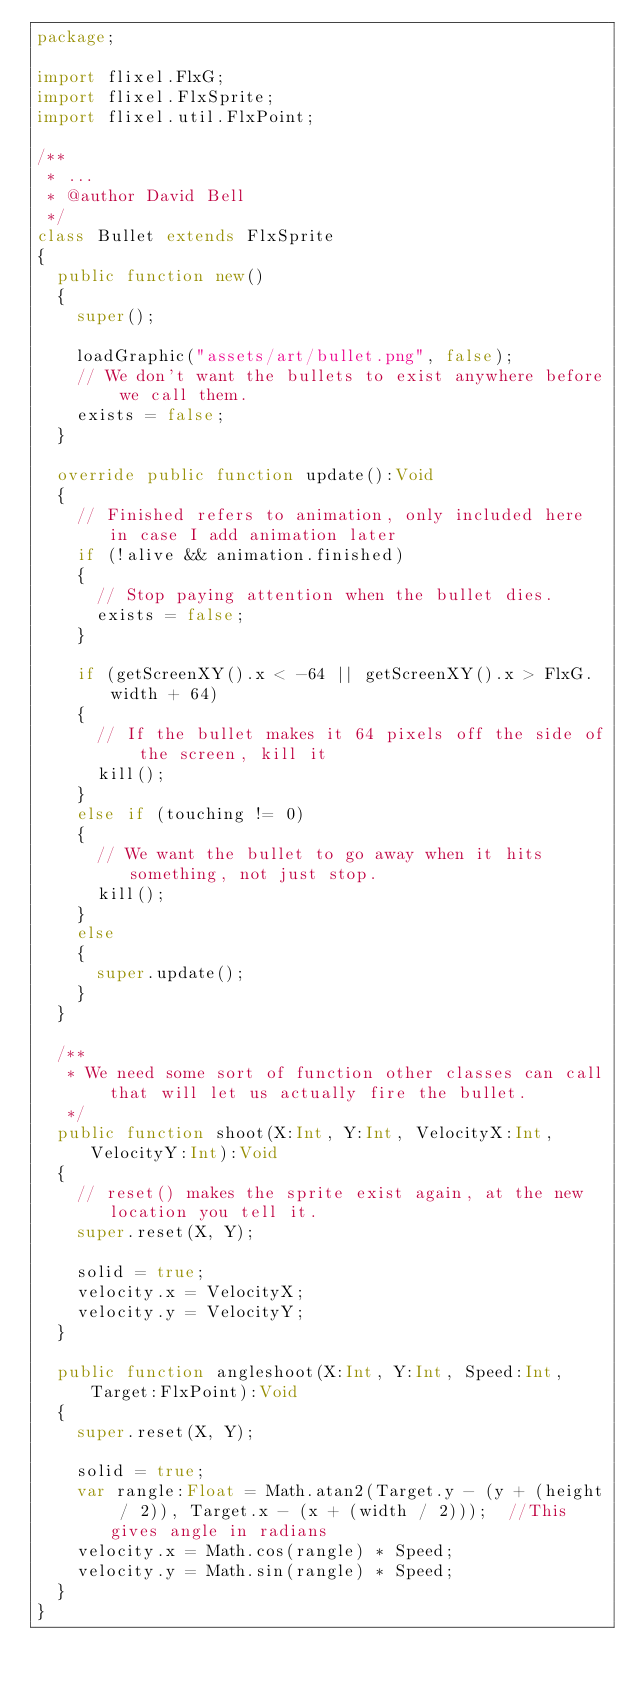<code> <loc_0><loc_0><loc_500><loc_500><_Haxe_>package;

import flixel.FlxG;
import flixel.FlxSprite;
import flixel.util.FlxPoint;

/**
 * ...
 * @author David Bell
 */
class Bullet extends FlxSprite 
{
	public function new() 
	{
		super();
		
		loadGraphic("assets/art/bullet.png", false);
		// We don't want the bullets to exist anywhere before we call them.
		exists = false; 
	}
	
	override public function update():Void 
	{
		// Finished refers to animation, only included here in case I add animation later
		if (!alive && animation.finished) 
		{
			// Stop paying attention when the bullet dies. 
			exists = false;   
		}
		
		if (getScreenXY().x < -64 || getScreenXY().x > FlxG.width + 64) 
		{ 
			// If the bullet makes it 64 pixels off the side of the screen, kill it
			kill(); 
		} 
		else if (touching != 0)
		{
			// We want the bullet to go away when it hits something, not just stop.
			kill(); 
		}
		else
		{
			super.update();
		}
	}
	
	/**
	 * We need some sort of function other classes can call that will let us actually fire the bullet. 
	 */ 
	public function shoot(X:Int, Y:Int, VelocityX:Int, VelocityY:Int):Void
	{
		// reset() makes the sprite exist again, at the new location you tell it.
		super.reset(X, Y);  
		
		solid = true;
		velocity.x = VelocityX;
		velocity.y = VelocityY;
	}
	
	public function angleshoot(X:Int, Y:Int, Speed:Int, Target:FlxPoint):Void
	{
		super.reset(X, Y);
		
		solid = true;
		var rangle:Float = Math.atan2(Target.y - (y + (height / 2)), Target.x - (x + (width / 2)));  //This gives angle in radians
		velocity.x = Math.cos(rangle) * Speed;
		velocity.y = Math.sin(rangle) * Speed;
	}
}</code> 